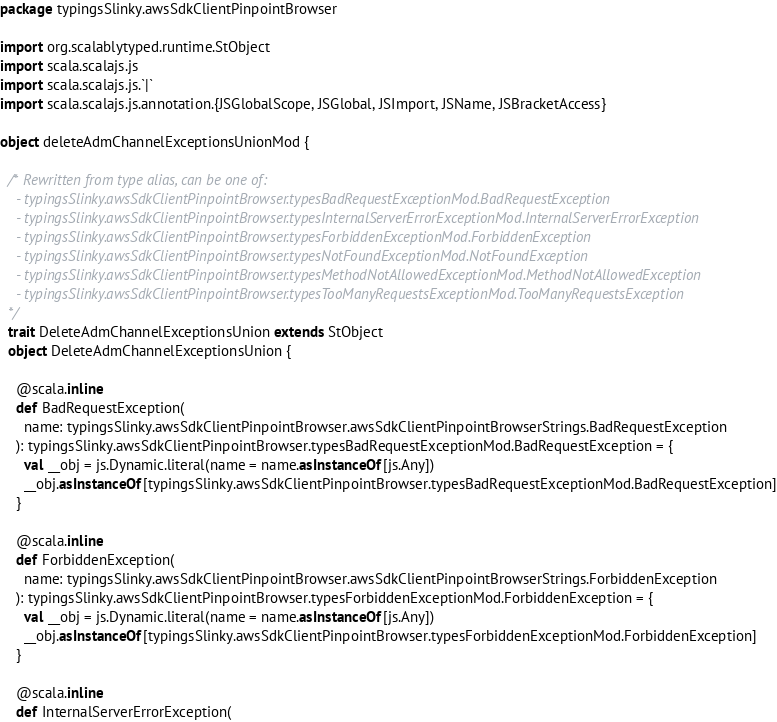Convert code to text. <code><loc_0><loc_0><loc_500><loc_500><_Scala_>package typingsSlinky.awsSdkClientPinpointBrowser

import org.scalablytyped.runtime.StObject
import scala.scalajs.js
import scala.scalajs.js.`|`
import scala.scalajs.js.annotation.{JSGlobalScope, JSGlobal, JSImport, JSName, JSBracketAccess}

object deleteAdmChannelExceptionsUnionMod {
  
  /* Rewritten from type alias, can be one of: 
    - typingsSlinky.awsSdkClientPinpointBrowser.typesBadRequestExceptionMod.BadRequestException
    - typingsSlinky.awsSdkClientPinpointBrowser.typesInternalServerErrorExceptionMod.InternalServerErrorException
    - typingsSlinky.awsSdkClientPinpointBrowser.typesForbiddenExceptionMod.ForbiddenException
    - typingsSlinky.awsSdkClientPinpointBrowser.typesNotFoundExceptionMod.NotFoundException
    - typingsSlinky.awsSdkClientPinpointBrowser.typesMethodNotAllowedExceptionMod.MethodNotAllowedException
    - typingsSlinky.awsSdkClientPinpointBrowser.typesTooManyRequestsExceptionMod.TooManyRequestsException
  */
  trait DeleteAdmChannelExceptionsUnion extends StObject
  object DeleteAdmChannelExceptionsUnion {
    
    @scala.inline
    def BadRequestException(
      name: typingsSlinky.awsSdkClientPinpointBrowser.awsSdkClientPinpointBrowserStrings.BadRequestException
    ): typingsSlinky.awsSdkClientPinpointBrowser.typesBadRequestExceptionMod.BadRequestException = {
      val __obj = js.Dynamic.literal(name = name.asInstanceOf[js.Any])
      __obj.asInstanceOf[typingsSlinky.awsSdkClientPinpointBrowser.typesBadRequestExceptionMod.BadRequestException]
    }
    
    @scala.inline
    def ForbiddenException(
      name: typingsSlinky.awsSdkClientPinpointBrowser.awsSdkClientPinpointBrowserStrings.ForbiddenException
    ): typingsSlinky.awsSdkClientPinpointBrowser.typesForbiddenExceptionMod.ForbiddenException = {
      val __obj = js.Dynamic.literal(name = name.asInstanceOf[js.Any])
      __obj.asInstanceOf[typingsSlinky.awsSdkClientPinpointBrowser.typesForbiddenExceptionMod.ForbiddenException]
    }
    
    @scala.inline
    def InternalServerErrorException(</code> 